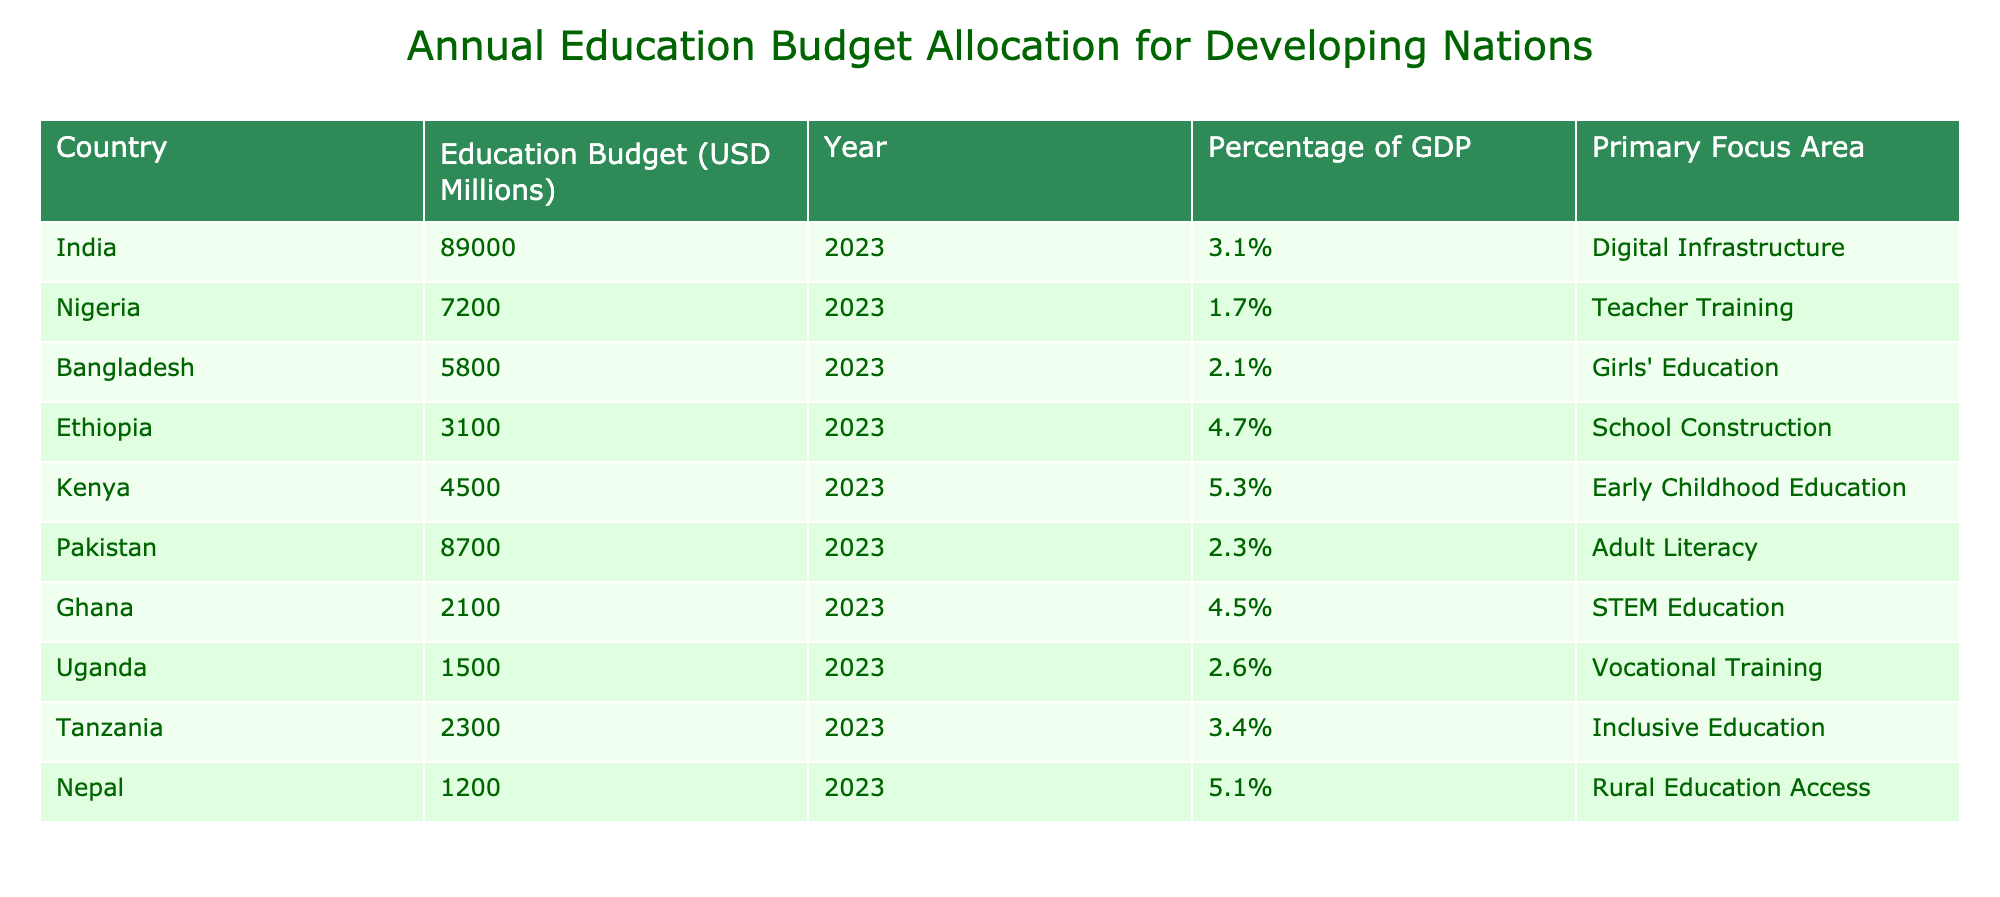What is the education budget for India? According to the table, India's education budget is listed as 89000 million USD for the year 2023.
Answer: 89000 million USD Which country has the highest percentage of GDP allocated to education? Ethiopia has the highest percentage of GDP, which is 4.7%, as indicated in the table.
Answer: Ethiopia What is the combined education budget of Nigeria, Bangladesh, and Ghana? The budgets for Nigeria (7200 million), Bangladesh (5800 million), and Ghana (2100 million) can be summed up: 7200 + 5800 + 2100 = 15100 million USD.
Answer: 15100 million USD Is the primary focus area for Kenya related to digital infrastructure? According to the table, Kenya's primary focus area is Early Childhood Education, not digital infrastructure. Thus, the statement is false.
Answer: No What is the average education budget allocation of the listed countries? The total budget for all countries is 89000 + 7200 + 5800 + 3100 + 4500 + 8700 + 2100 + 1500 + 2300 + 1200 = 103700 million USD, and there are 10 countries, so the average is 103700/10 = 10370 million USD.
Answer: 10370 million USD Do all countries in the table have an education budget above 1000 million USD? All the countries listed in the table have education budgets above 1000 million USD, as the lowest budget (Nepal) is 1200 million USD. Therefore, the statement is true.
Answer: Yes Which country focuses on STEM Education? Ghana is specifically mentioned as focusing on STEM Education according to the data.
Answer: Ghana If we consider only the countries with a primary focus on girls' education and vocational training, what is their total education budget? Only Bangladesh (5800 million) focuses on girls' education and Uganda (1500 million) on vocational training. The total is 5800 + 1500 = 7300 million USD.
Answer: 7300 million USD What percentage of GDP is allocated to education in Pakistan? The table shows that Pakistan allocates 2.3% of its GDP for education.
Answer: 2.3% 